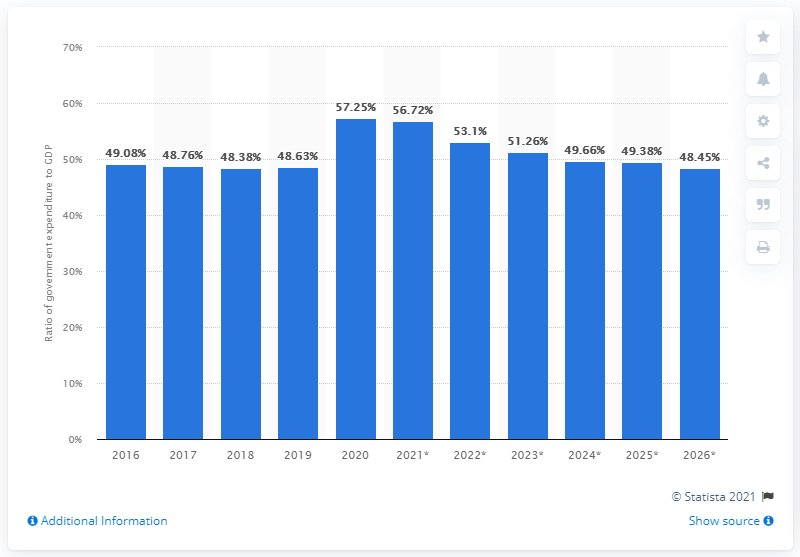Outline some significant characteristics in this image. In 2020, the government of Italy spent approximately 56.72% of the country's Gross Domestic Product (GDP). 